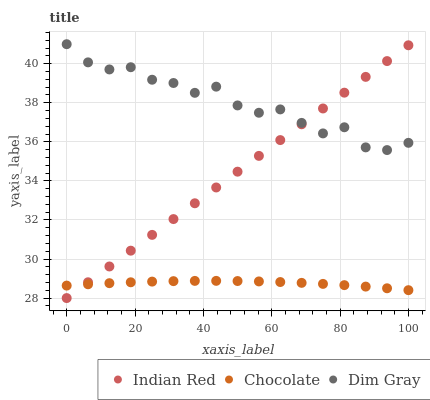Does Chocolate have the minimum area under the curve?
Answer yes or no. Yes. Does Dim Gray have the maximum area under the curve?
Answer yes or no. Yes. Does Indian Red have the minimum area under the curve?
Answer yes or no. No. Does Indian Red have the maximum area under the curve?
Answer yes or no. No. Is Indian Red the smoothest?
Answer yes or no. Yes. Is Dim Gray the roughest?
Answer yes or no. Yes. Is Chocolate the smoothest?
Answer yes or no. No. Is Chocolate the roughest?
Answer yes or no. No. Does Indian Red have the lowest value?
Answer yes or no. Yes. Does Chocolate have the lowest value?
Answer yes or no. No. Does Dim Gray have the highest value?
Answer yes or no. Yes. Does Indian Red have the highest value?
Answer yes or no. No. Is Chocolate less than Dim Gray?
Answer yes or no. Yes. Is Dim Gray greater than Chocolate?
Answer yes or no. Yes. Does Indian Red intersect Chocolate?
Answer yes or no. Yes. Is Indian Red less than Chocolate?
Answer yes or no. No. Is Indian Red greater than Chocolate?
Answer yes or no. No. Does Chocolate intersect Dim Gray?
Answer yes or no. No. 